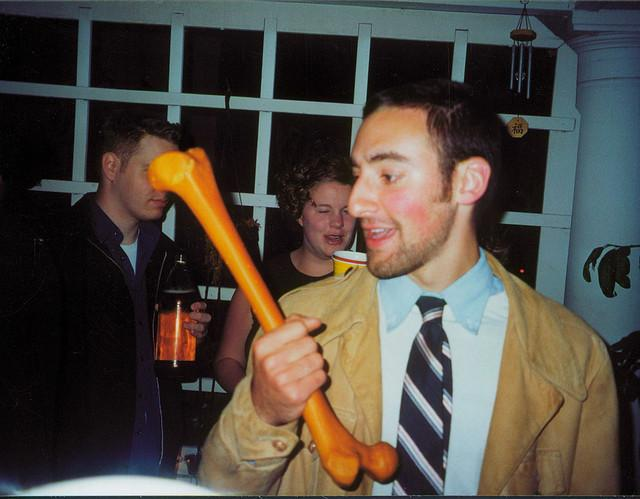What is the orange object called? Please explain your reasoning. bone. The object has the shape of a bone. 